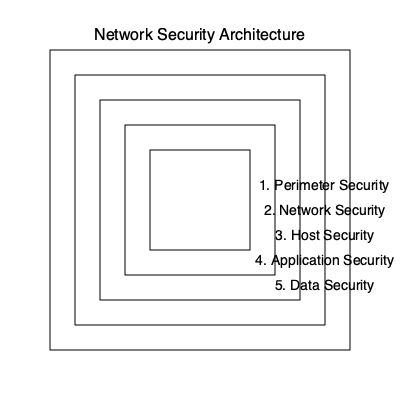In the context of an e-commerce platform's network security architecture, which layer would be most appropriate for implementing database encryption and access controls to protect sensitive customer information? To answer this question, let's examine each layer of the network security architecture:

1. Perimeter Security: This outermost layer focuses on protecting the network boundary, typically using firewalls and intrusion detection systems.

2. Network Security: This layer involves securing the internal network infrastructure, including switches, routers, and network segmentation.

3. Host Security: This layer deals with securing individual devices and servers within the network, such as implementing antivirus software and host-based firewalls.

4. Application Security: This layer involves securing the applications running on the network, including web application firewalls and secure coding practices.

5. Data Security: This innermost layer focuses on protecting the data itself, regardless of where it's stored or transmitted within the network.

For an e-commerce platform, sensitive customer information is typically stored in databases. To protect this data, we need to implement security measures at the data level, which includes database encryption and access controls. These measures ensure that even if other layers are compromised, the data itself remains secure.

Therefore, the most appropriate layer for implementing database encryption and access controls to protect sensitive customer information is the Data Security layer (layer 5 in the diagram).
Answer: Data Security layer 